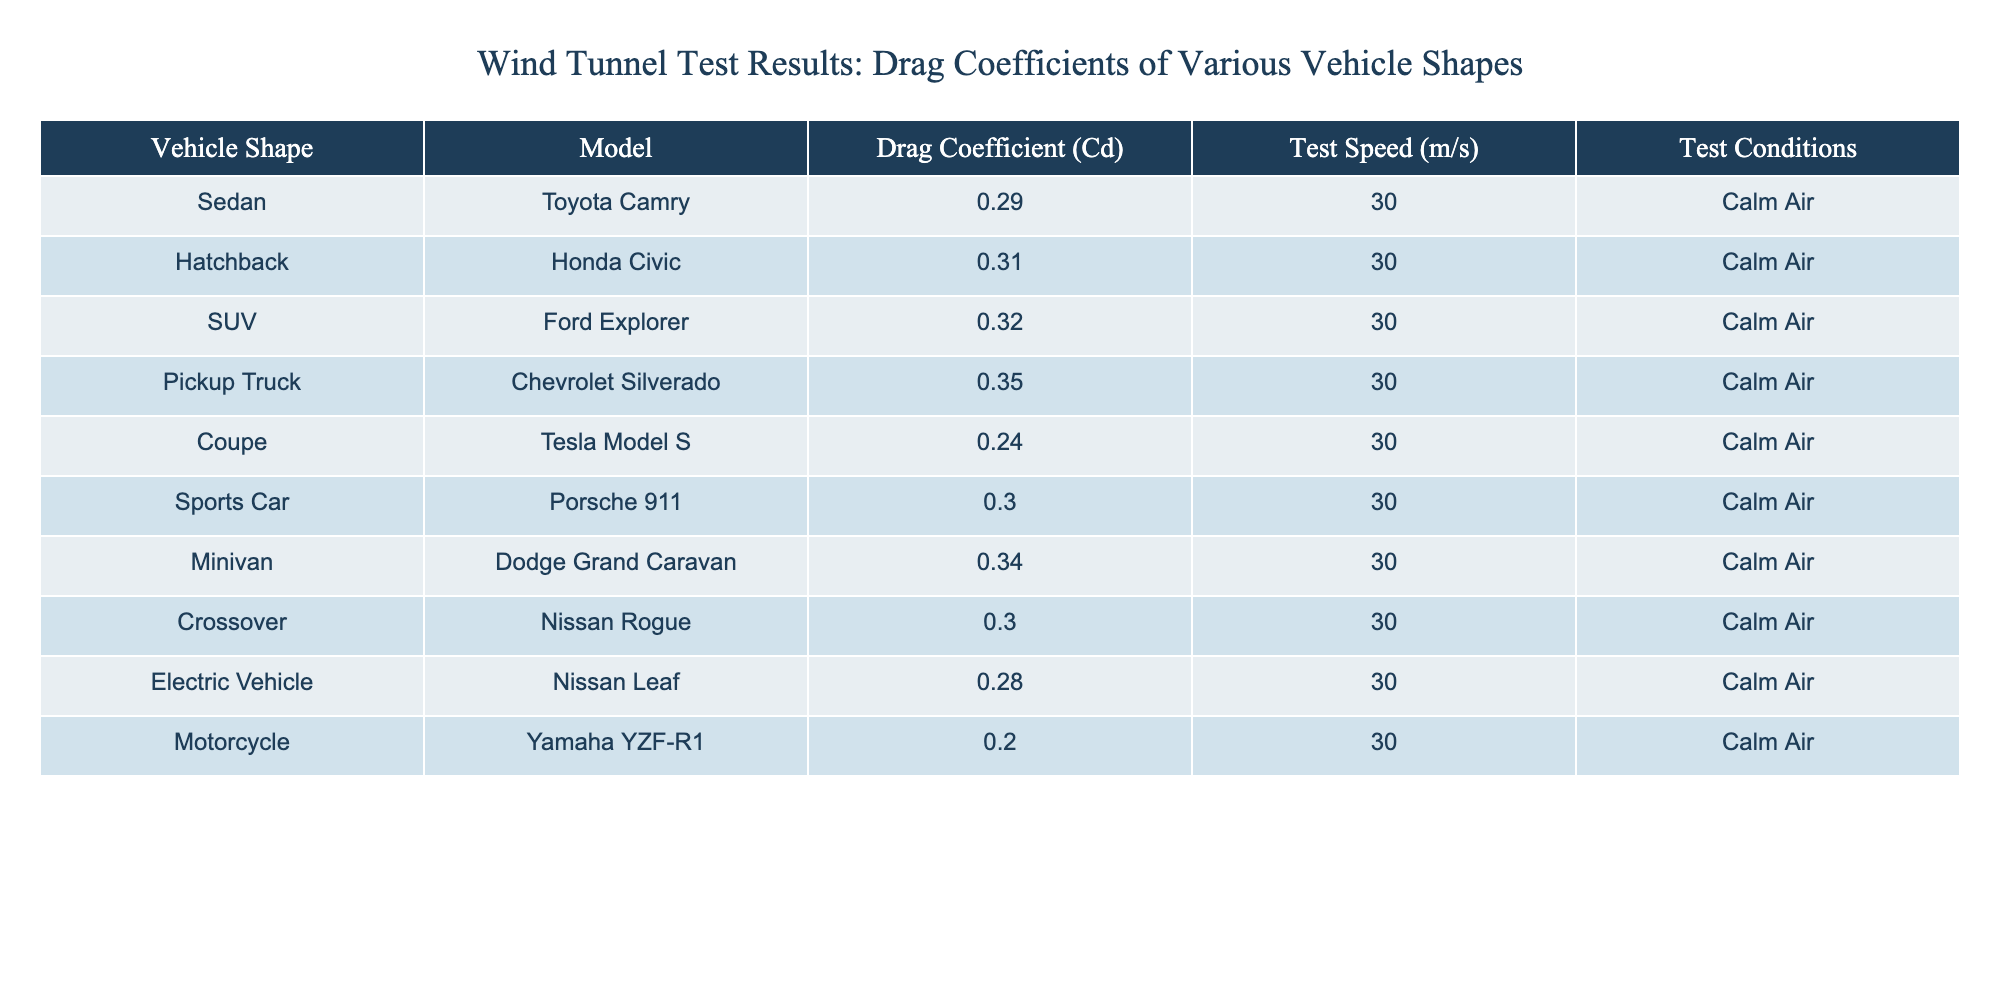What is the drag coefficient of the Tesla Model S? The table lists the Tesla Model S under the "Coupe" category with a drag coefficient of 0.24.
Answer: 0.24 Which vehicle has the highest drag coefficient? By examining the "Drag Coefficient (Cd)" values, the Chevrolet Silverado has the highest value at 0.35 among the listed vehicles.
Answer: Chevrolet Silverado What is the average drag coefficient of the vehicles tested? To find the average, sum all drag coefficients: (0.29 + 0.31 + 0.32 + 0.35 + 0.24 + 0.30 + 0.34 + 0.30 + 0.28 + 0.20) = 3.2. There are 10 vehicles, so the average is 3.2/10 = 0.32.
Answer: 0.32 Is the drag coefficient of the Nissan Leaf lower than that of the Honda Civic? The Nissan Leaf has a drag coefficient of 0.28, while the Honda Civic has a drag coefficient of 0.31. Since 0.28 is less than 0.31, the statement is true.
Answer: Yes How much lower is the drag coefficient of the Yamaha YZF-R1 compared to that of the Ford Explorer? The Yamaha YZF-R1’s drag coefficient is 0.20 and the Ford Explorer's is 0.32. The difference is 0.32 - 0.20 = 0.12, indicating that the Yamaha YZF-R1 has a lower drag coefficient by this amount.
Answer: 0.12 How many vehicles have a drag coefficient greater than 0.30? Examining the table, the vehicles with a drag coefficient greater than 0.30 are the Ford Explorer, Chevrolet Silverado, Dodge Grand Caravan, and the Honda Civic. That's a total of 4 vehicles.
Answer: 4 What percentage of the vehicles have a drag coefficient less than 0.30? The vehicles with a drag coefficient less than 0.30 are the Tesla Model S (0.24), Nissan Leaf (0.28), and Yamaha YZF-R1 (0.20), which makes 3 out of 10 vehicles. The percentage is (3/10)*100 = 30%.
Answer: 30% Which vehicle shapes have the same drag coefficient? Analyzing the table, the Porsche 911 and Nissan Rogue both have a drag coefficient of 0.30, indicating they share this value.
Answer: Porsche 911 and Nissan Rogue 